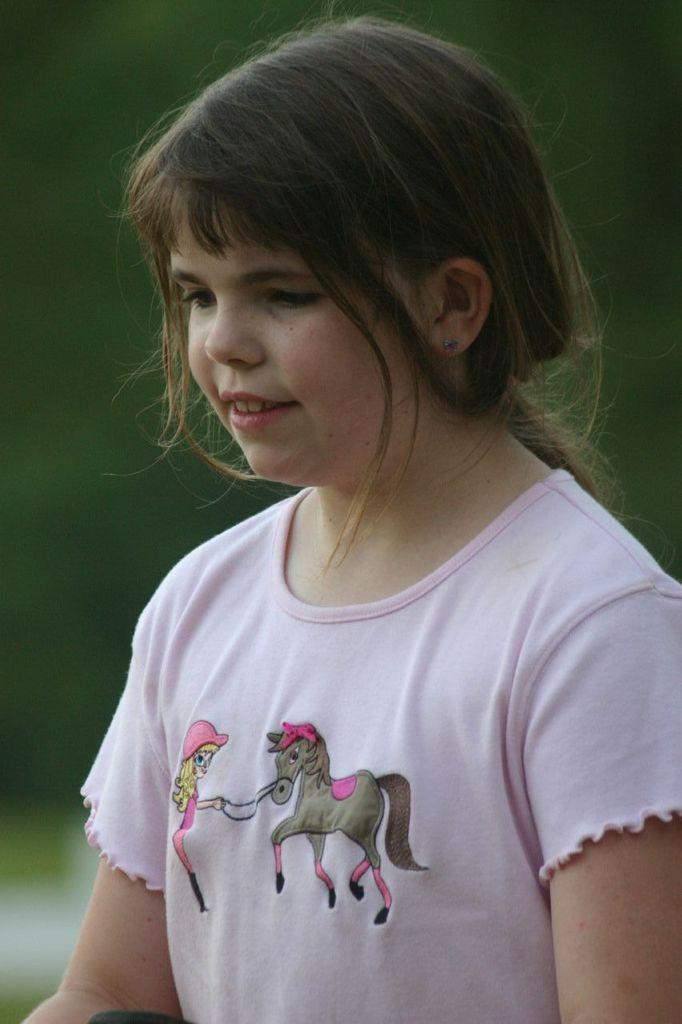Who is the main subject in the image? There is a girl in the image. What is the girl's expression in the image? The girl is smiling in the image. Can you describe the background of the image? The background of the image is blurry. What does the moon regret in the image? There is no moon present in the image, so it cannot be said that the moon regrets anything. 